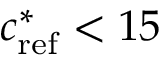<formula> <loc_0><loc_0><loc_500><loc_500>c _ { r e f } ^ { * } < 1 5</formula> 